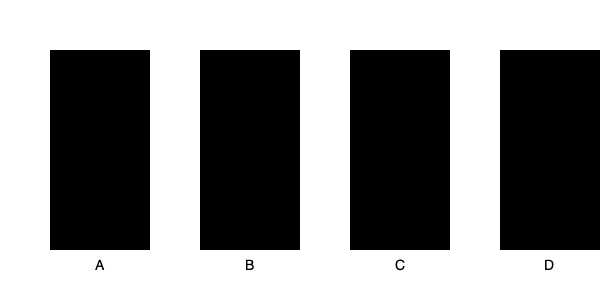Identify the silhouette that represents the "Triangle Choke" grappling technique: To identify the Triangle Choke silhouette, let's analyze each image:

1. Image A: This silhouette shows a figure with legs wrapped around the opponent's neck and arm, forming a triangular shape. This is characteristic of the Triangle Choke.

2. Image B: This silhouette depicts a figure in a mounted position on top of another, not representative of the Triangle Choke.

3. Image C: This silhouette shows a figure applying an armbar, with legs across the opponent's chest and arm extended.

4. Image D: This silhouette represents a rear naked choke, with the attacker behind the opponent.

The Triangle Choke is performed by wrapping one's legs around the opponent's neck and one arm, forming a triangle shape with the legs. This creates a powerful chokehold using the legs to constrict blood flow. Based on these characteristics, Image A most accurately represents the Triangle Choke technique.
Answer: A 